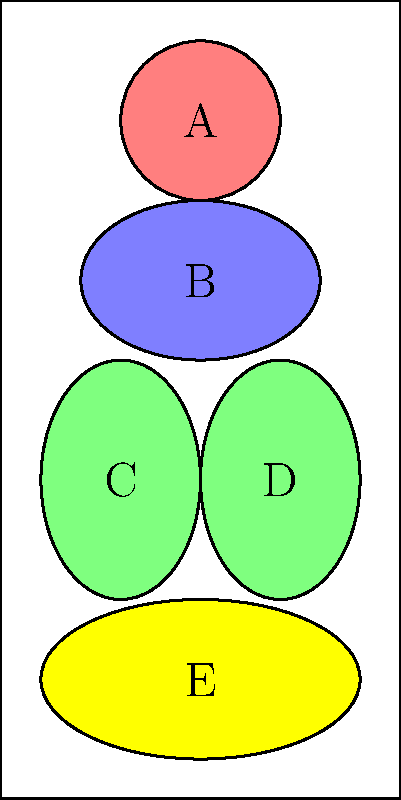In the given human torso diagram, which letter corresponds to the liver? To identify the liver in this simplified human torso diagram, we need to consider the following steps:

1. Recognize the general layout of major organs in the human torso:
   - The heart is typically located in the upper chest, slightly to the left.
   - The lungs occupy the upper chest area on both sides of the heart.
   - The liver is the largest internal organ, located in the upper right quadrant of the abdomen.
   - The stomach is typically on the left side of the upper abdomen.
   - The intestines occupy the lower abdominal area.

2. Analyze the diagram:
   - A: Circular shape in the upper chest, likely representing the heart.
   - B: Large oval shape below A, possibly representing a lung.
   - C and D: Two similar shapes on either side of the lower torso, likely representing kidneys.
   - E: Large oval shape at the bottom, possibly representing intestines.

3. Identify the liver:
   - The liver should be a large organ on the right side of the upper abdomen.
   - In this simplified diagram, the organ labeled D is in the correct position for the liver.
   - It is larger than C (likely the left kidney) and positioned higher in the torso.

4. Conclude:
   Based on its size and position in the upper right quadrant of the abdomen, the organ labeled D most likely represents the liver.
Answer: D 